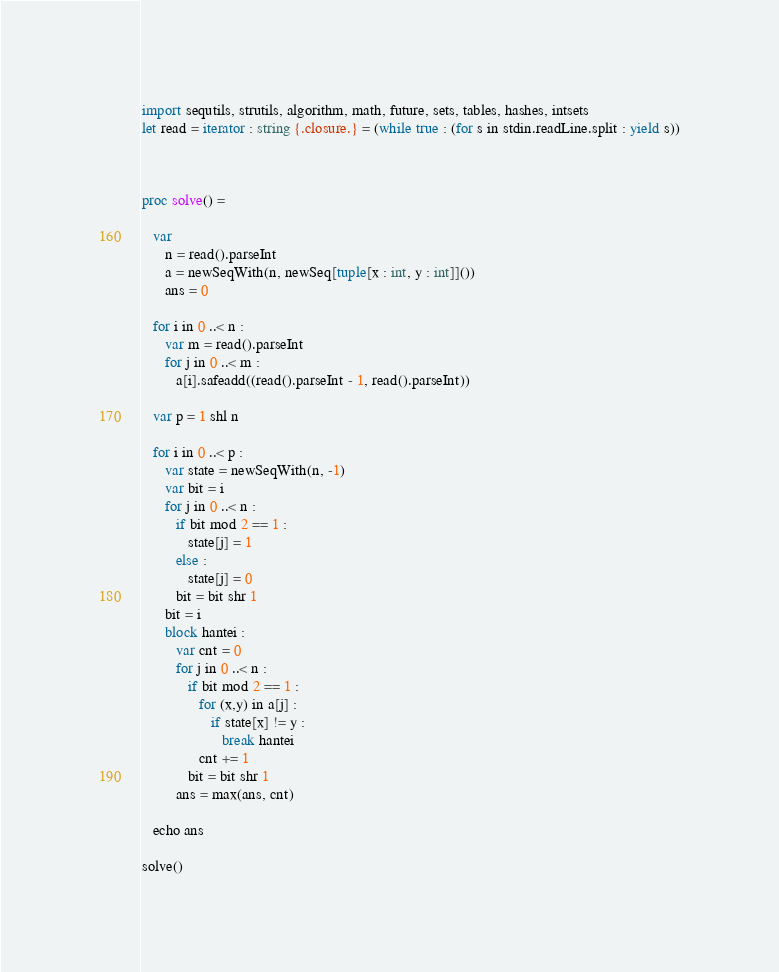Convert code to text. <code><loc_0><loc_0><loc_500><loc_500><_Nim_>import sequtils, strutils, algorithm, math, future, sets, tables, hashes, intsets
let read = iterator : string {.closure.} = (while true : (for s in stdin.readLine.split : yield s))



proc solve() =
   
   var
      n = read().parseInt
      a = newSeqWith(n, newSeq[tuple[x : int, y : int]]())
      ans = 0

   for i in 0 ..< n : 
      var m = read().parseInt
      for j in 0 ..< m : 
         a[i].safeadd((read().parseInt - 1, read().parseInt))

   var p = 1 shl n

   for i in 0 ..< p : 
      var state = newSeqWith(n, -1)
      var bit = i
      for j in 0 ..< n : 
         if bit mod 2 == 1 : 
            state[j] = 1
         else : 
            state[j] = 0
         bit = bit shr 1
      bit = i
      block hantei :
         var cnt = 0
         for j in 0 ..< n : 
            if bit mod 2 == 1 : 
               for (x,y) in a[j] : 
                  if state[x] != y :
                     break hantei
               cnt += 1
            bit = bit shr 1
         ans = max(ans, cnt)
   
   echo ans

solve()</code> 